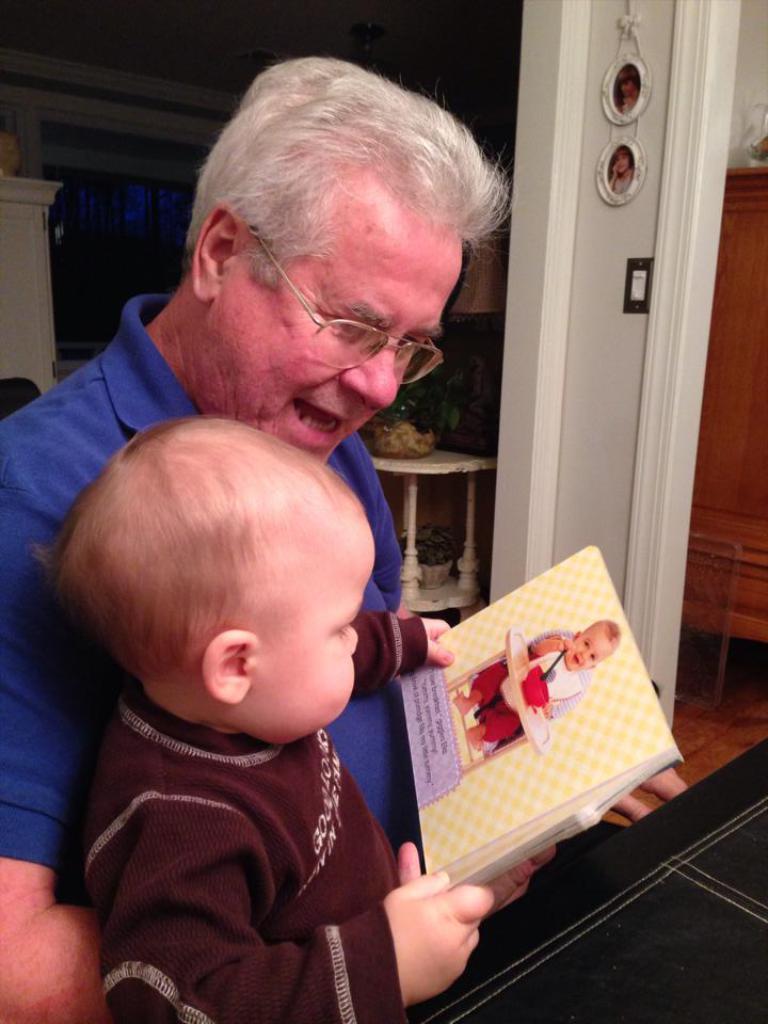How would you summarize this image in a sentence or two? In this image a person wearing a blue shirt is holding a baby in her arms. Baby is wearing a brown shirt. He is holding a book. Behind this person there is a table having a bowl on it. There is a picture frame attached to the wall, beside there is a wooden furniture. 